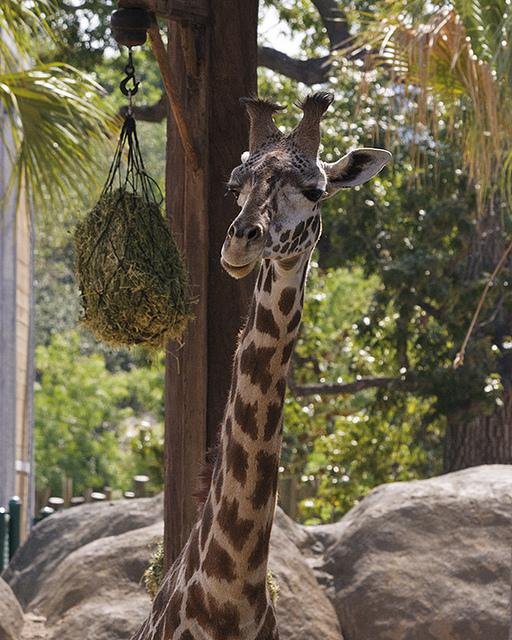What is the animal doing?
Quick response, please. Eating. Is the giraffe interested in the object on the tree?
Be succinct. Yes. What is hanging down in front of the giraffe?
Write a very short answer. Grass. 